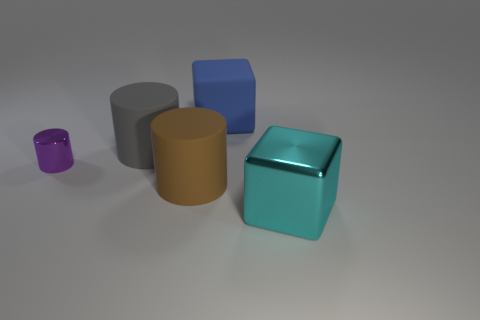Subtract all large cylinders. How many cylinders are left? 1 Add 3 small gray cylinders. How many objects exist? 8 Subtract 1 cylinders. How many cylinders are left? 2 Subtract all cylinders. How many objects are left? 2 Add 1 shiny blocks. How many shiny blocks are left? 2 Add 4 blue rubber things. How many blue rubber things exist? 5 Subtract 0 purple balls. How many objects are left? 5 Subtract all large cyan blocks. Subtract all cubes. How many objects are left? 2 